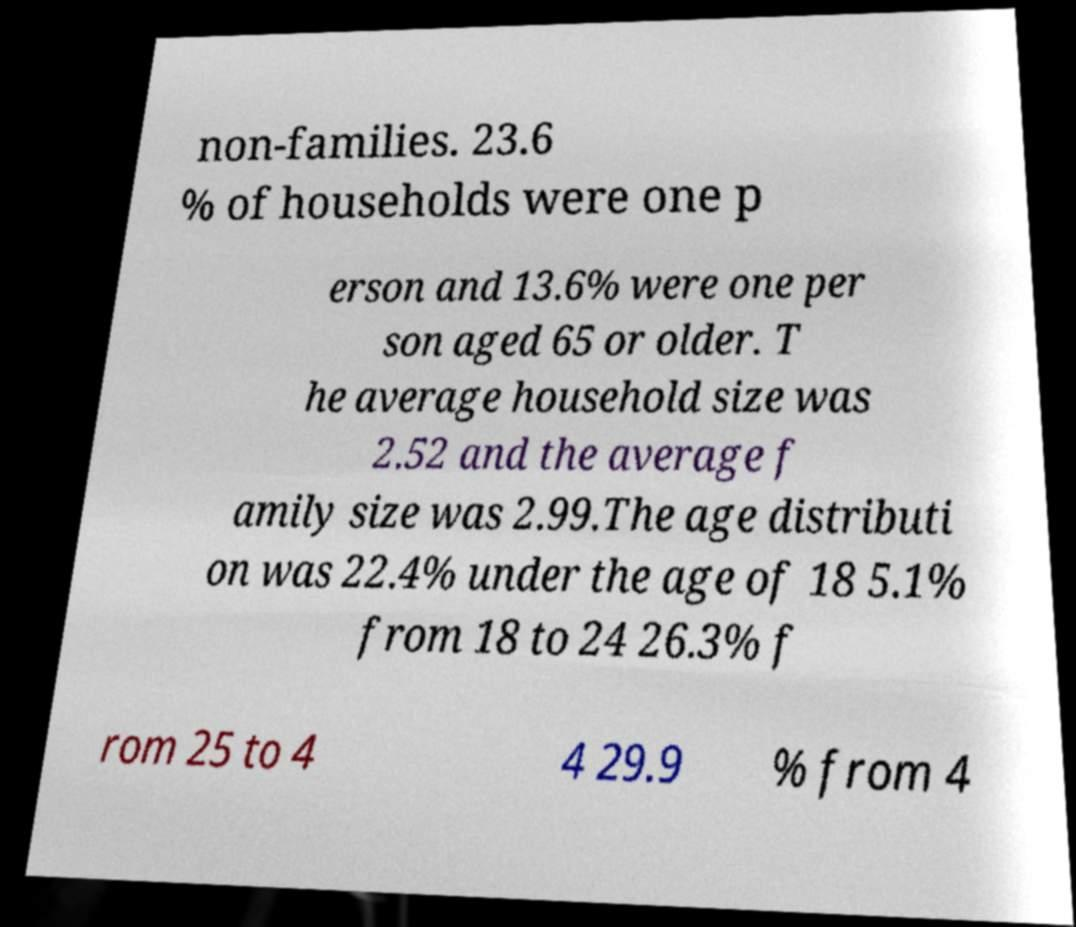Could you assist in decoding the text presented in this image and type it out clearly? non-families. 23.6 % of households were one p erson and 13.6% were one per son aged 65 or older. T he average household size was 2.52 and the average f amily size was 2.99.The age distributi on was 22.4% under the age of 18 5.1% from 18 to 24 26.3% f rom 25 to 4 4 29.9 % from 4 